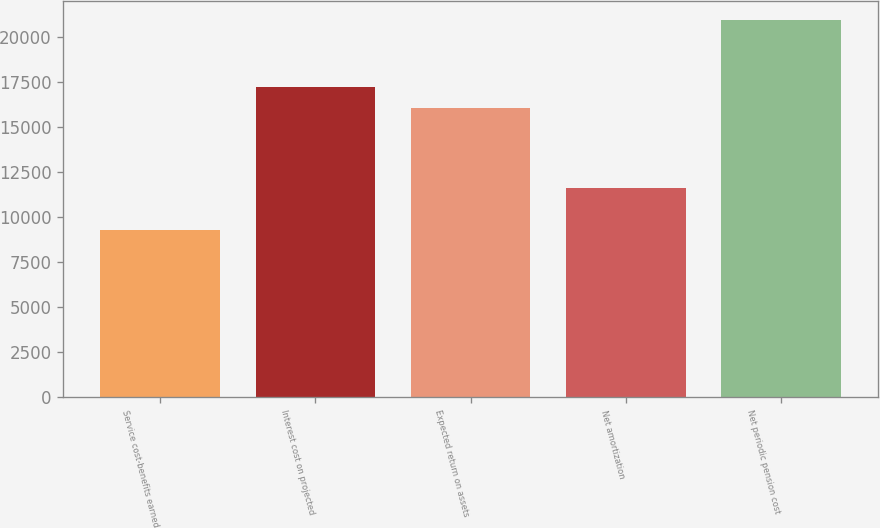Convert chart. <chart><loc_0><loc_0><loc_500><loc_500><bar_chart><fcel>Service cost-benefits earned<fcel>Interest cost on projected<fcel>Expected return on assets<fcel>Net amortization<fcel>Net periodic pension cost<nl><fcel>9277<fcel>17235.5<fcel>16068<fcel>11637<fcel>20952<nl></chart> 